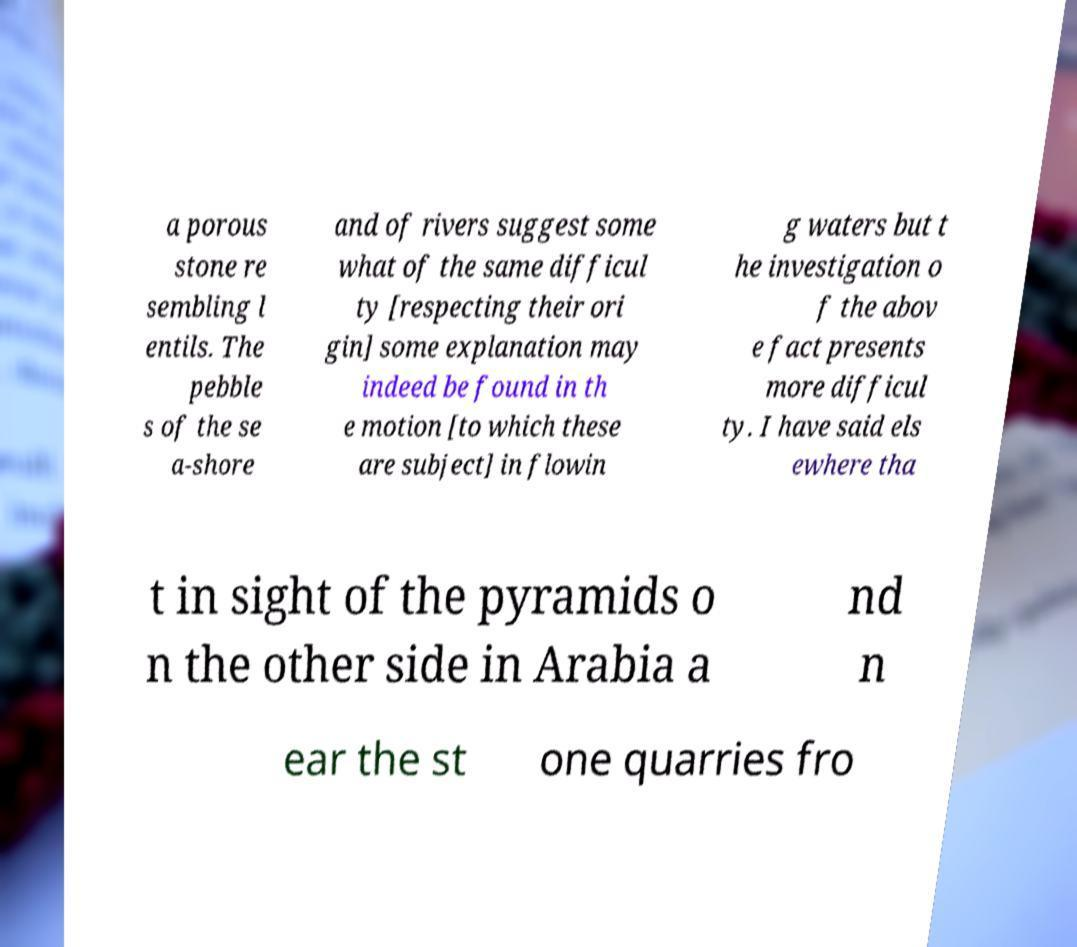There's text embedded in this image that I need extracted. Can you transcribe it verbatim? a porous stone re sembling l entils. The pebble s of the se a-shore and of rivers suggest some what of the same difficul ty [respecting their ori gin] some explanation may indeed be found in th e motion [to which these are subject] in flowin g waters but t he investigation o f the abov e fact presents more difficul ty. I have said els ewhere tha t in sight of the pyramids o n the other side in Arabia a nd n ear the st one quarries fro 